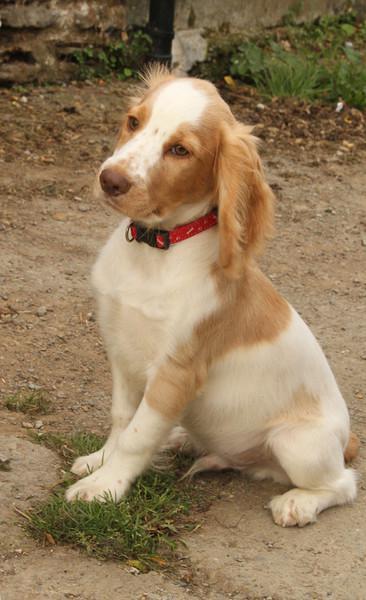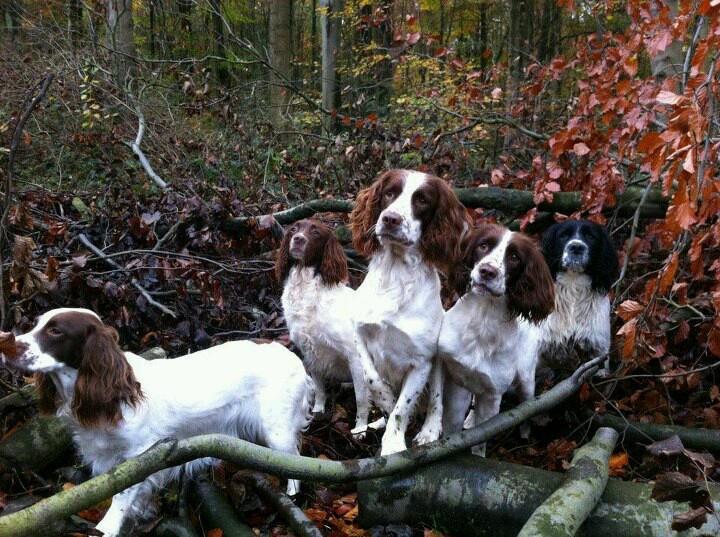The first image is the image on the left, the second image is the image on the right. Evaluate the accuracy of this statement regarding the images: "One of the dogs is white with black spots.". Is it true? Answer yes or no. No. The first image is the image on the left, the second image is the image on the right. Given the left and right images, does the statement "One image shows one leftward turned brown-and-white spaniel that is sitting upright outdoors." hold true? Answer yes or no. Yes. 